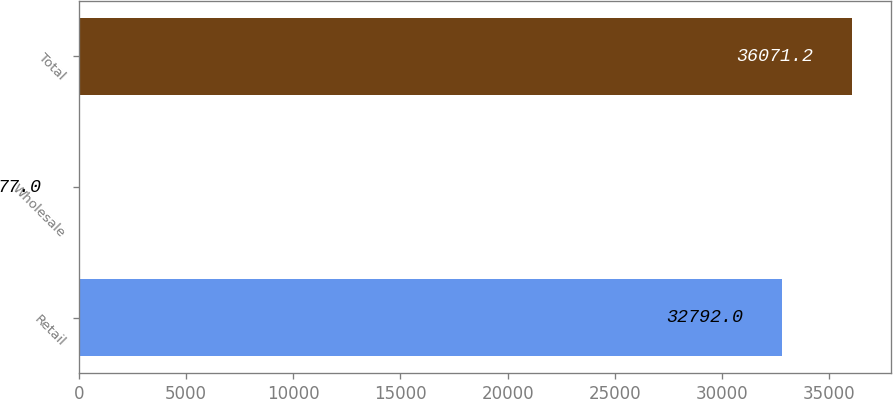Convert chart. <chart><loc_0><loc_0><loc_500><loc_500><bar_chart><fcel>Retail<fcel>Wholesale<fcel>Total<nl><fcel>32792<fcel>77<fcel>36071.2<nl></chart> 